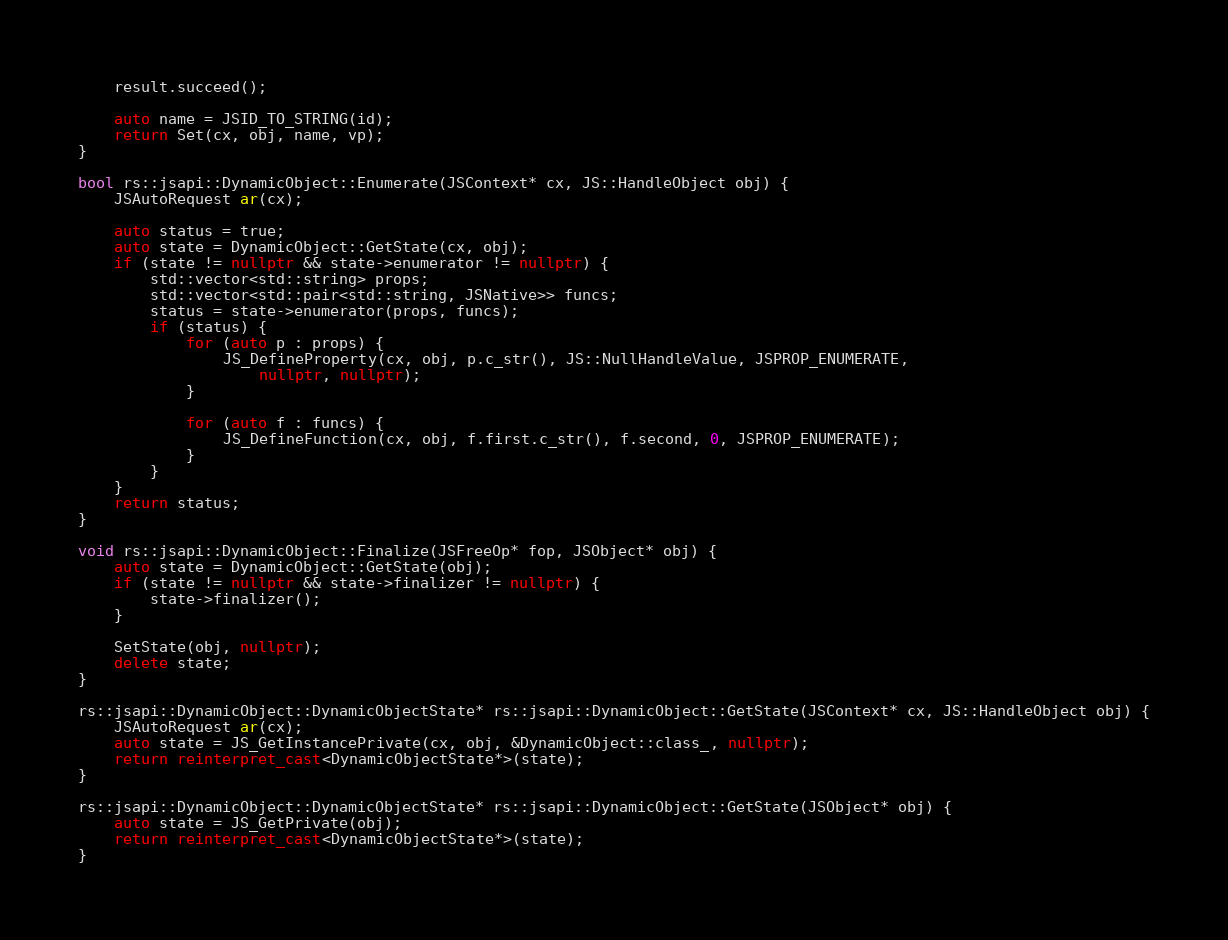<code> <loc_0><loc_0><loc_500><loc_500><_C++_>    result.succeed();
    
    auto name = JSID_TO_STRING(id);
    return Set(cx, obj, name, vp);
}

bool rs::jsapi::DynamicObject::Enumerate(JSContext* cx, JS::HandleObject obj) {
    JSAutoRequest ar(cx);

    auto status = true;
    auto state = DynamicObject::GetState(cx, obj);
    if (state != nullptr && state->enumerator != nullptr) {
        std::vector<std::string> props;
        std::vector<std::pair<std::string, JSNative>> funcs;
        status = state->enumerator(props, funcs);
        if (status) {
            for (auto p : props) {
                JS_DefineProperty(cx, obj, p.c_str(), JS::NullHandleValue, JSPROP_ENUMERATE, 
                    nullptr, nullptr);
            }
            
            for (auto f : funcs) {
                JS_DefineFunction(cx, obj, f.first.c_str(), f.second, 0, JSPROP_ENUMERATE);
            }
        }
    }
    return status;
}

void rs::jsapi::DynamicObject::Finalize(JSFreeOp* fop, JSObject* obj) {
    auto state = DynamicObject::GetState(obj);
    if (state != nullptr && state->finalizer != nullptr) {
        state->finalizer();
    }
    
    SetState(obj, nullptr);
    delete state;    
}

rs::jsapi::DynamicObject::DynamicObjectState* rs::jsapi::DynamicObject::GetState(JSContext* cx, JS::HandleObject obj) {
    JSAutoRequest ar(cx);    
    auto state = JS_GetInstancePrivate(cx, obj, &DynamicObject::class_, nullptr);
    return reinterpret_cast<DynamicObjectState*>(state);
}

rs::jsapi::DynamicObject::DynamicObjectState* rs::jsapi::DynamicObject::GetState(JSObject* obj) {
    auto state = JS_GetPrivate(obj);
    return reinterpret_cast<DynamicObjectState*>(state);
}
</code> 